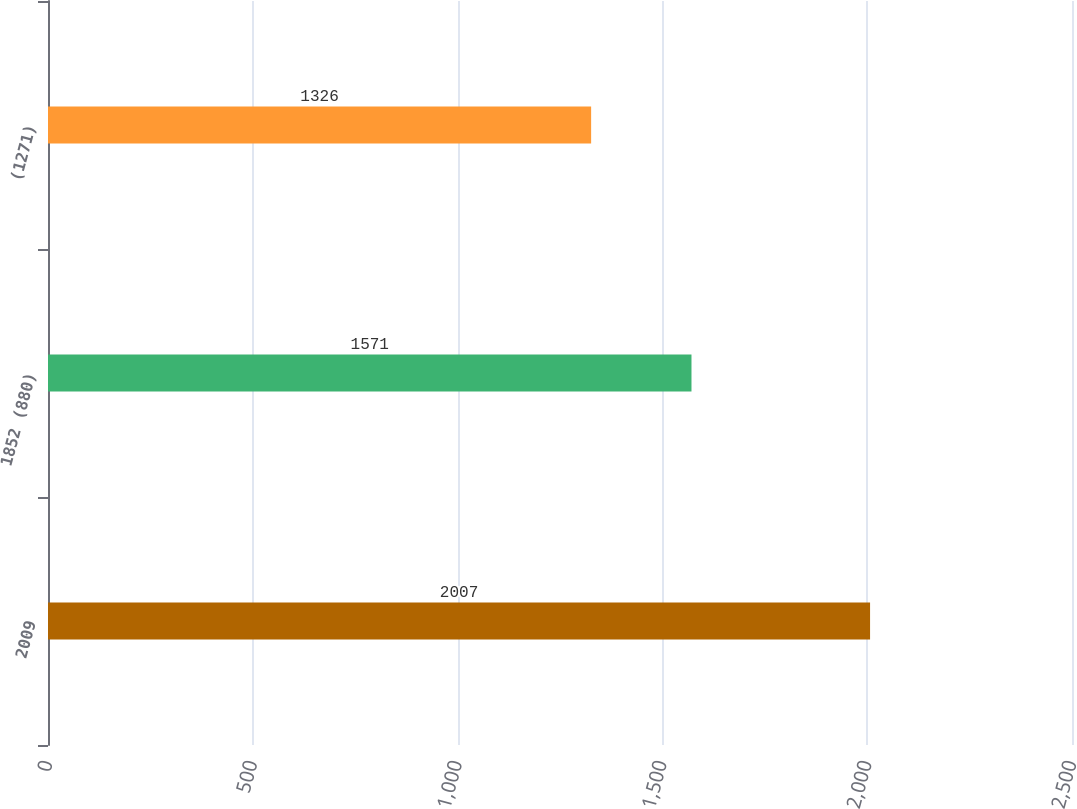Convert chart to OTSL. <chart><loc_0><loc_0><loc_500><loc_500><bar_chart><fcel>2009<fcel>1852 (880)<fcel>(1271)<nl><fcel>2007<fcel>1571<fcel>1326<nl></chart> 